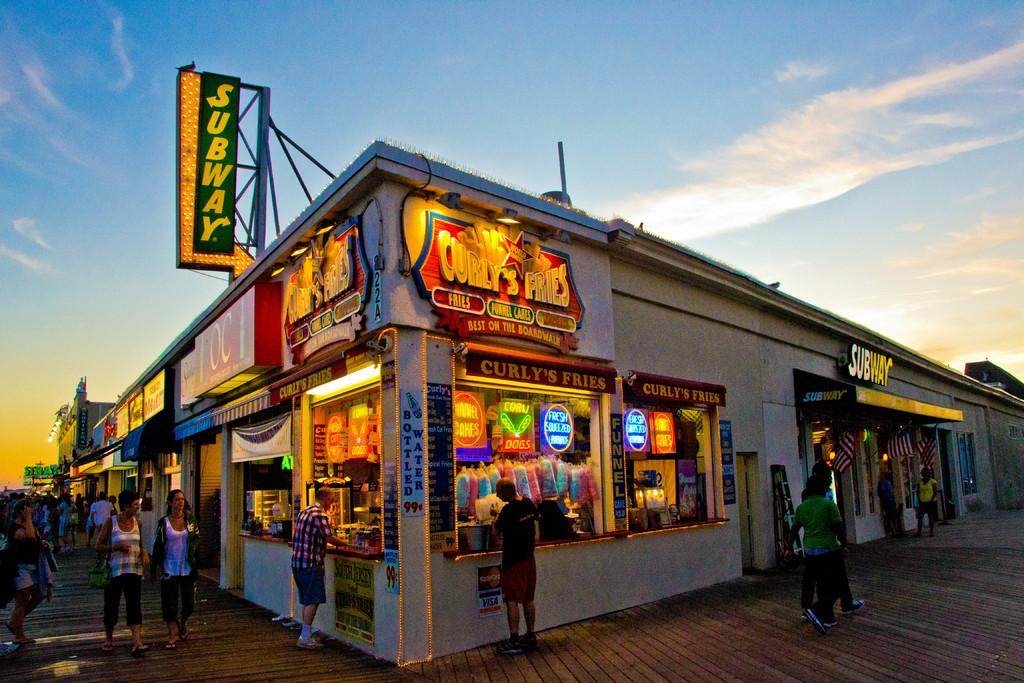What type of buildings are in the center of the image? There are stores in the center of the image. What is located at the bottom of the image? There is a road at the bottom of the image. What are the people in the image doing? People are walking on the road. What type of machine is being used to control people's minds in the image? There is no machine present in the image that controls people's minds. What are the people talking about while walking on the road? The image does not provide information about what the people are talking about while walking on the road. 